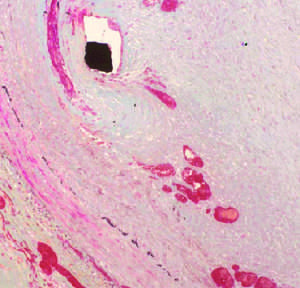does the histologic view show a thickened neointima overlying the stent wires (black diamond indicated by the arrow), which encroaches on the lumen (asterisk)?
Answer the question using a single word or phrase. Yes 